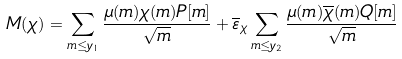Convert formula to latex. <formula><loc_0><loc_0><loc_500><loc_500>M ( \chi ) = \sum _ { m \leq y _ { 1 } } \frac { \mu ( m ) \chi ( m ) P [ m ] } { \sqrt { m } } + \overline { \varepsilon } _ { \chi } \sum _ { m \leq y _ { 2 } } \frac { \mu ( m ) \overline { \chi } ( m ) Q [ m ] } { \sqrt { m } }</formula> 